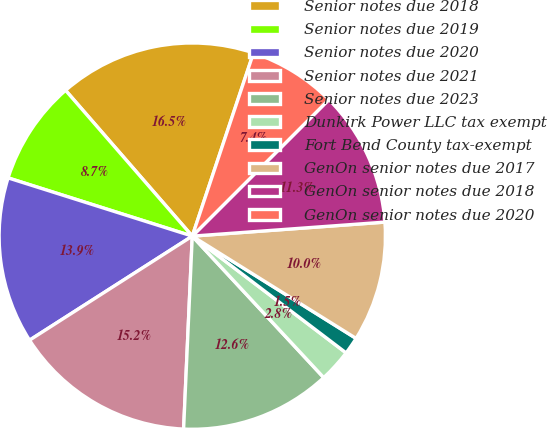Convert chart to OTSL. <chart><loc_0><loc_0><loc_500><loc_500><pie_chart><fcel>Senior notes due 2018<fcel>Senior notes due 2019<fcel>Senior notes due 2020<fcel>Senior notes due 2021<fcel>Senior notes due 2023<fcel>Dunkirk Power LLC tax exempt<fcel>Fort Bend County tax-exempt<fcel>GenOn senior notes due 2017<fcel>GenOn senior notes due 2018<fcel>GenOn senior notes due 2020<nl><fcel>16.52%<fcel>8.74%<fcel>13.93%<fcel>15.23%<fcel>12.63%<fcel>2.75%<fcel>1.45%<fcel>10.04%<fcel>11.34%<fcel>7.37%<nl></chart> 